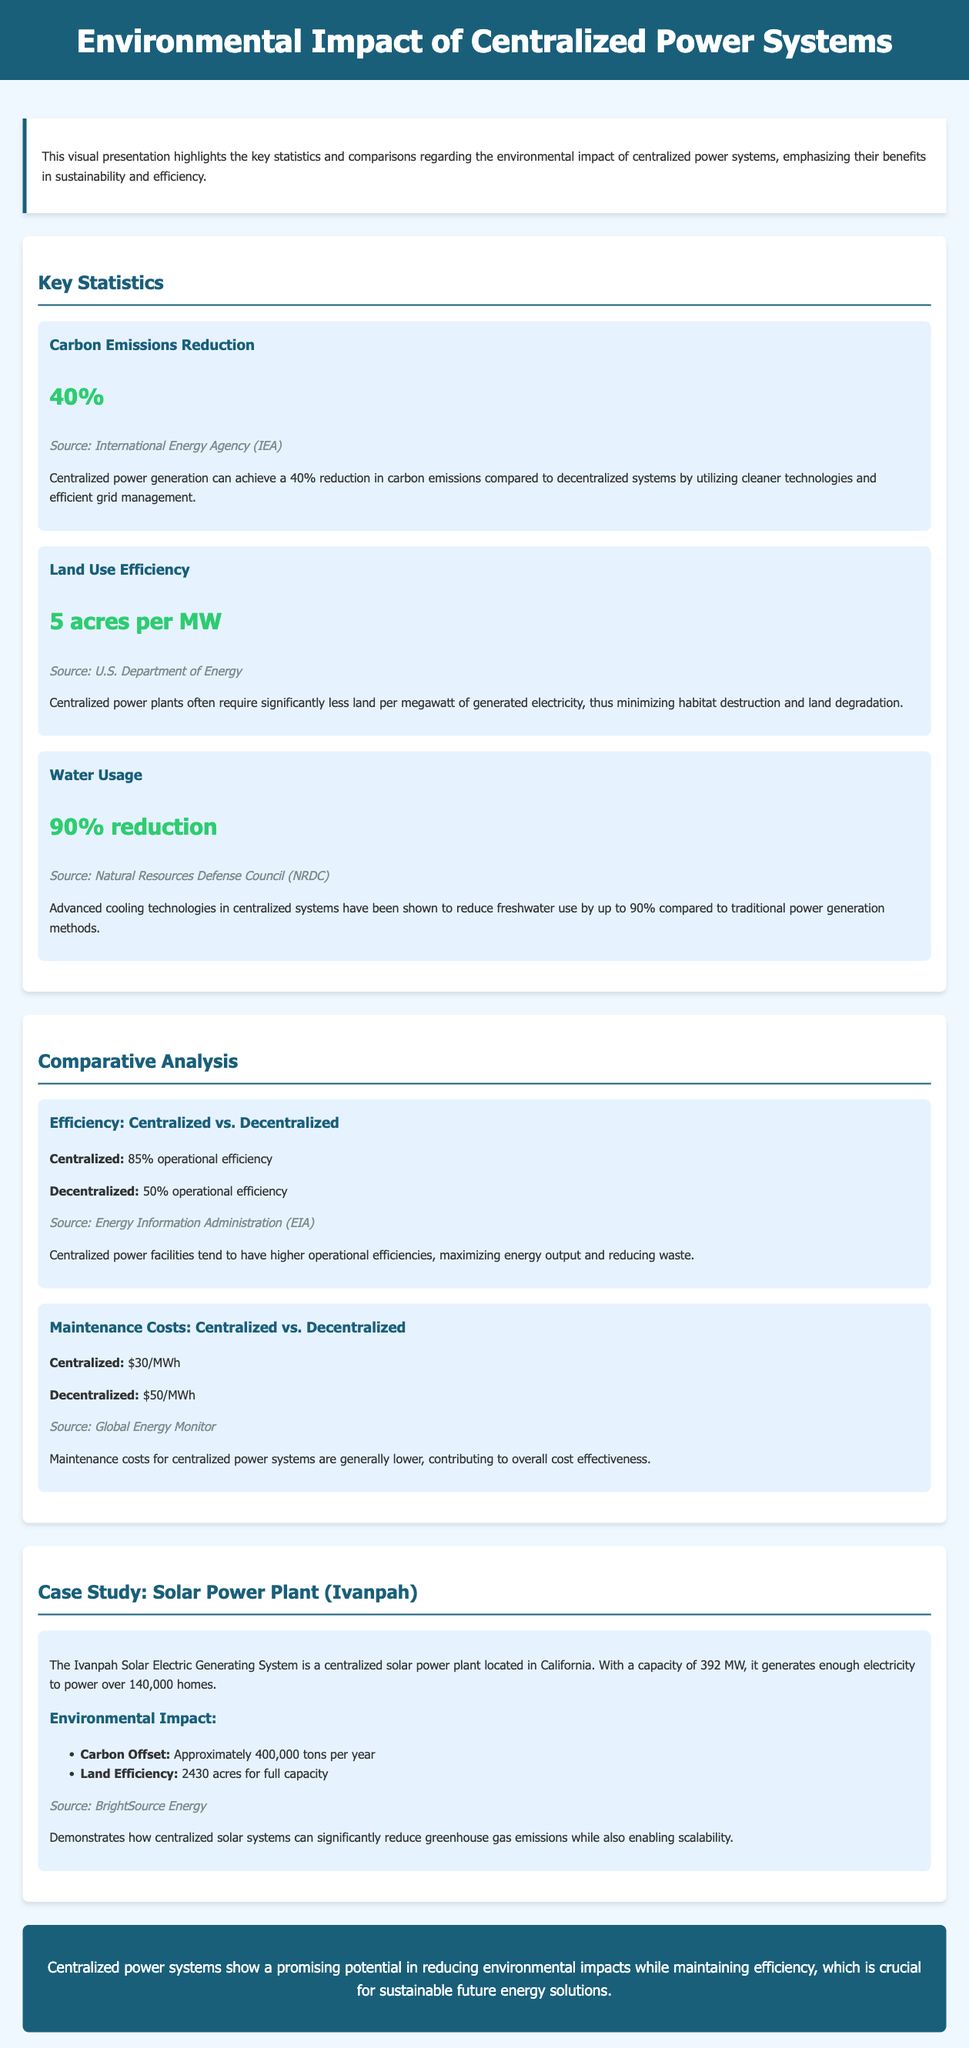What is the percentage reduction in carbon emissions? The document states that centralized power generation can achieve a 40% reduction in carbon emissions compared to decentralized systems.
Answer: 40% What is the land use requirement for centralized power plants? According to the document, centralized power plants often require 5 acres per megawatt of generated electricity.
Answer: 5 acres per MW What is the operational efficiency of centralized power systems? The document mentions that centralized power facilities tend to have an 85% operational efficiency.
Answer: 85% What are the maintenance costs for decentralized power systems? The document indicates that maintenance costs for decentralized systems are $50 per megawatt hour (MWh).
Answer: $50/MWh How much carbon is offset by the Ivanpah Solar Power Plant annually? The case study on the Ivanpah Solar Electric Generating System states an approximate carbon offset of 400,000 tons per year.
Answer: 400,000 tons per year What is the water usage reduction achieved by centralized systems? The document highlights a 90% reduction in freshwater use compared to traditional power generation methods.
Answer: 90% reduction What is the source of the land use efficiency statistic? The document attributes the land use efficiency statistic to the U.S. Department of Energy.
Answer: U.S. Department of Energy What capacity does the Ivanpah Solar Plant have? The document states that the Ivanpah Solar Electric Generating System has a capacity of 392 megawatts (MW).
Answer: 392 MW What type of document is this? The structure and content indicate that this is a visual presentation focusing on the environmental impact of centralized power systems.
Answer: Visual presentation 